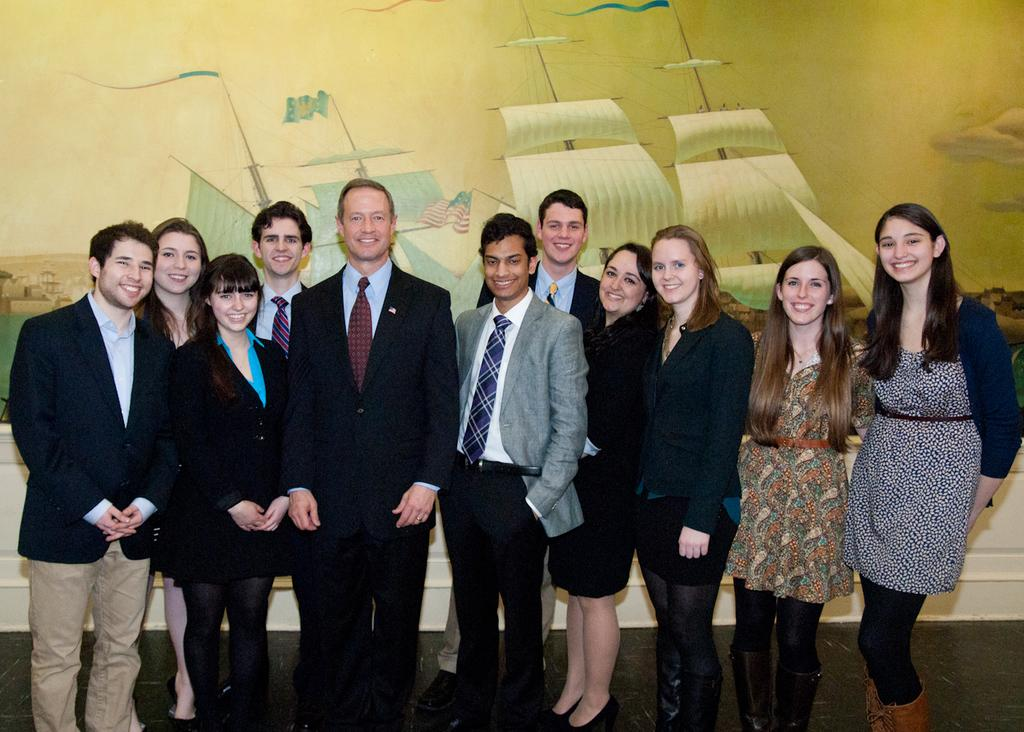What is the main subject of the image? The main subject of the image is a group of people. Where are the people located in the image? The people are standing on the floor in the image. What expression do the people have in the image? The people are smiling in the image. What can be seen in the background of the image? There is a poster on the wall in the background of the image. What type of farm animals can be seen in the image? There are no farm animals present in the image. Is there a woman in the image? The provided facts do not mention the presence of a woman in the image. --- Facts: 1. There is a car in the image. 2. The car is parked on the street. 3. The car has four wheels. 4. There is a traffic light near the car. 5. The traffic light is red. Absurd Topics: parrot, ocean, dance Conversation: What is the main subject of the image? The main subject of the image is a car. Where is the car located in the image? The car is parked on the street in the image. How many wheels does the car have? The car has four wheels. What can be seen near the car in the image? There is a traffic light near the car in the image. What color is the traffic light in the image? The traffic light is red in the image. Reasoning: Let's think step by step in order to produce the conversation. We start by identifying the main subject of the image, which is the car. Then, we describe its location, the number of wheels, and the presence of a traffic light nearby. We also mention the color of the traffic light, which is red. Each question is designed to elicit a specific detail about the image that is known from the provided facts. Absurd Question/Answer: Can you see a parrot dancing in the ocean in the image? There is no parrot or ocean present in the image, and therefore no such activity can be observed. 